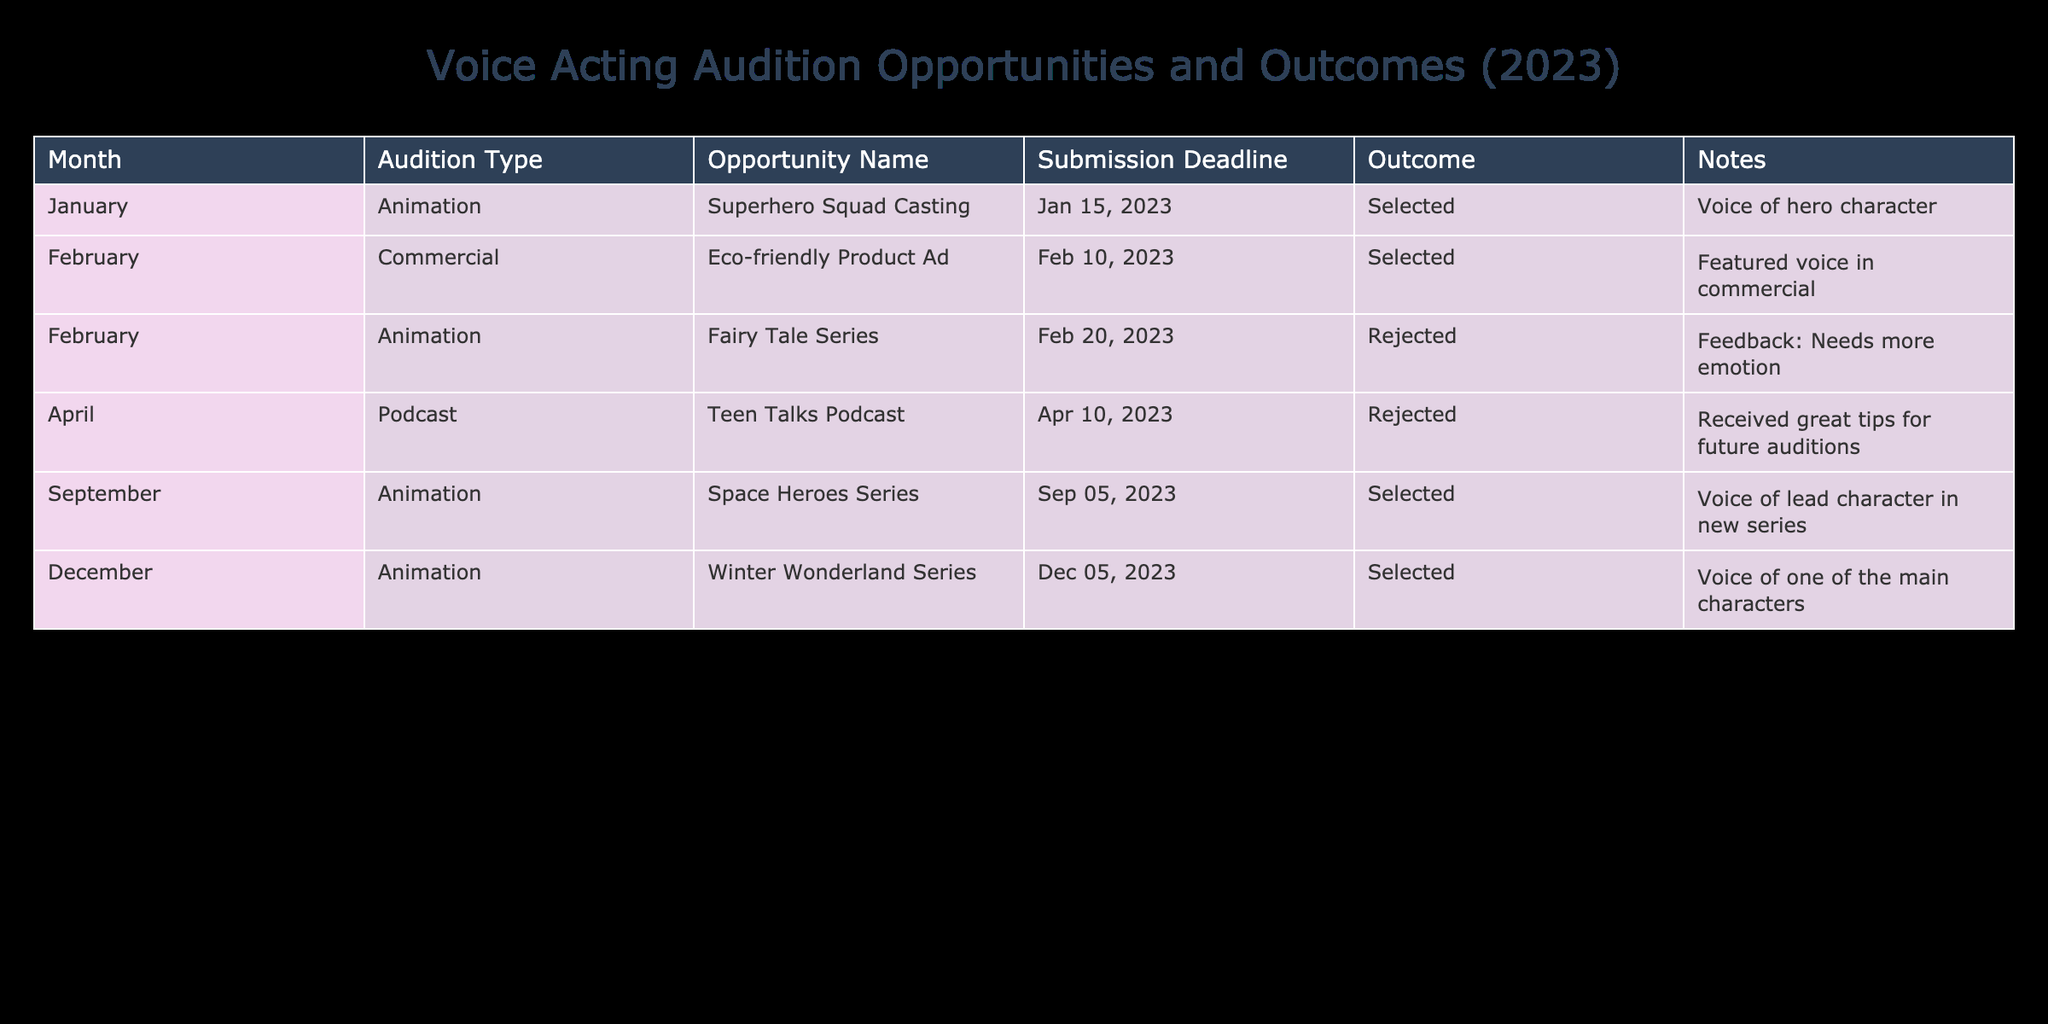What audition type was the most frequent in 2023? By examining the "Audition Type" column in the table, we can see that "Animation" appears four times (January, February, September, December), whereas "Commercial" and "Podcast" only appear once each. Therefore, the audition type that was most frequent is "Animation."
Answer: Animation How many auditions were ultimately successful? From the "Outcome" column, we can identify that there are three "Selected" outcomes (January, February, September, and December). Counting these events gives a total of four successful auditions.
Answer: 4 What was the outcome of the audition for the "Eco-friendly Product Ad"? Looking at the "Outcome" column for the specific audition named "Eco-friendly Product Ad," we find that it states "Selected." This means the audition was successful.
Answer: Selected Did you receive feedback for the audition in February? By checking the "Notes" column for the auditions in February, particularly the one for the "Fairy Tale Series," it mentions receiving feedback stating "Needs more emotion." This indicates that feedback was indeed provided.
Answer: Yes Which audition had the latest submission deadline and what was the outcome? To determine which audition had the latest submission deadline, we look at the "Submission Deadline" column. The latest date is "December 5, 2023," associated with the audition "Winter Wonderland Series," which has the outcome of "Selected."
Answer: Winter Wonderland Series, Selected How many auditions were rejected in total? By reviewing the "Outcome" column, we can identify the number of "Rejected" outcomes. There are two instances (February and April) where audits received a rejected status. Therefore, the total number of rejected auditions is two.
Answer: 2 In which month did you have the most unsuccessful auditions? The months of February and April both had unsuccessful auditions, with one rejection each. However, since both months have the same number of rejections, they are tied for this outcome.
Answer: February and April How many different opportunities were there in total throughout the year? To find the total number of different audition opportunities, you can count each entry listed in the "Opportunity Name" column. There are a total of six unique auditions throughout the year.
Answer: 6 